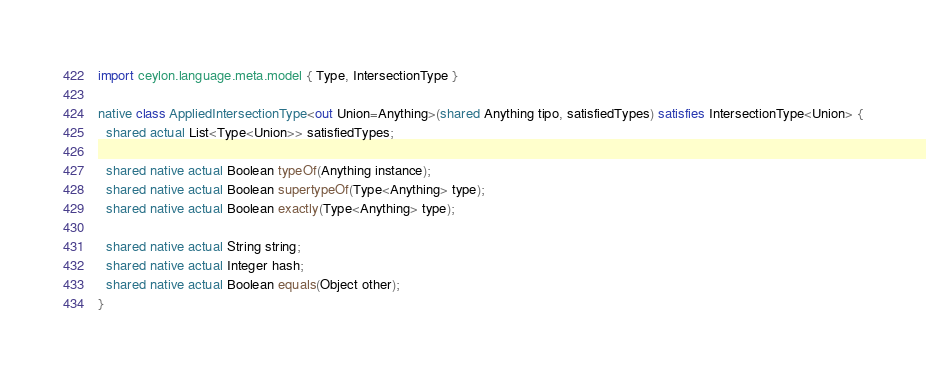<code> <loc_0><loc_0><loc_500><loc_500><_Ceylon_>import ceylon.language.meta.model { Type, IntersectionType }

native class AppliedIntersectionType<out Union=Anything>(shared Anything tipo, satisfiedTypes) satisfies IntersectionType<Union> {
  shared actual List<Type<Union>> satisfiedTypes;

  shared native actual Boolean typeOf(Anything instance);
  shared native actual Boolean supertypeOf(Type<Anything> type);
  shared native actual Boolean exactly(Type<Anything> type);

  shared native actual String string;
  shared native actual Integer hash;
  shared native actual Boolean equals(Object other);
}
</code> 